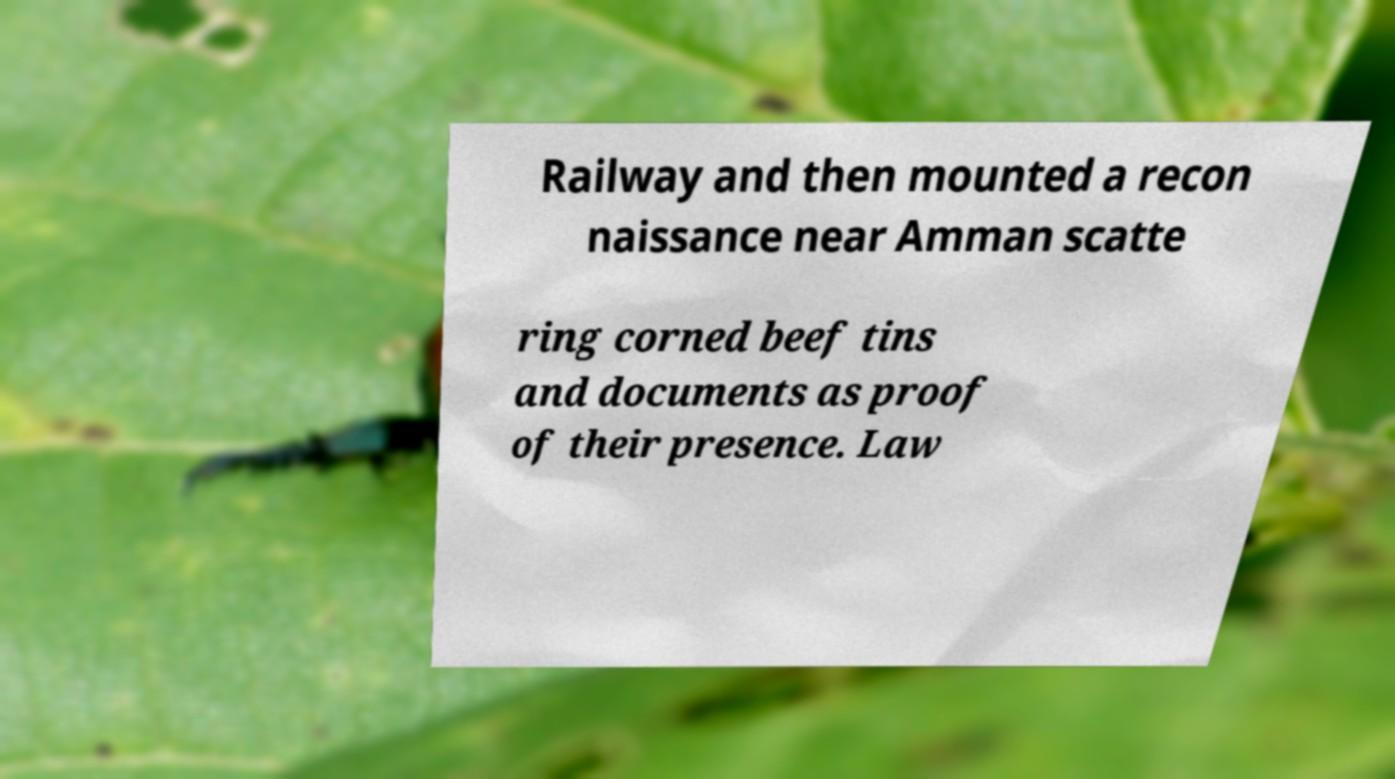For documentation purposes, I need the text within this image transcribed. Could you provide that? Railway and then mounted a recon naissance near Amman scatte ring corned beef tins and documents as proof of their presence. Law 